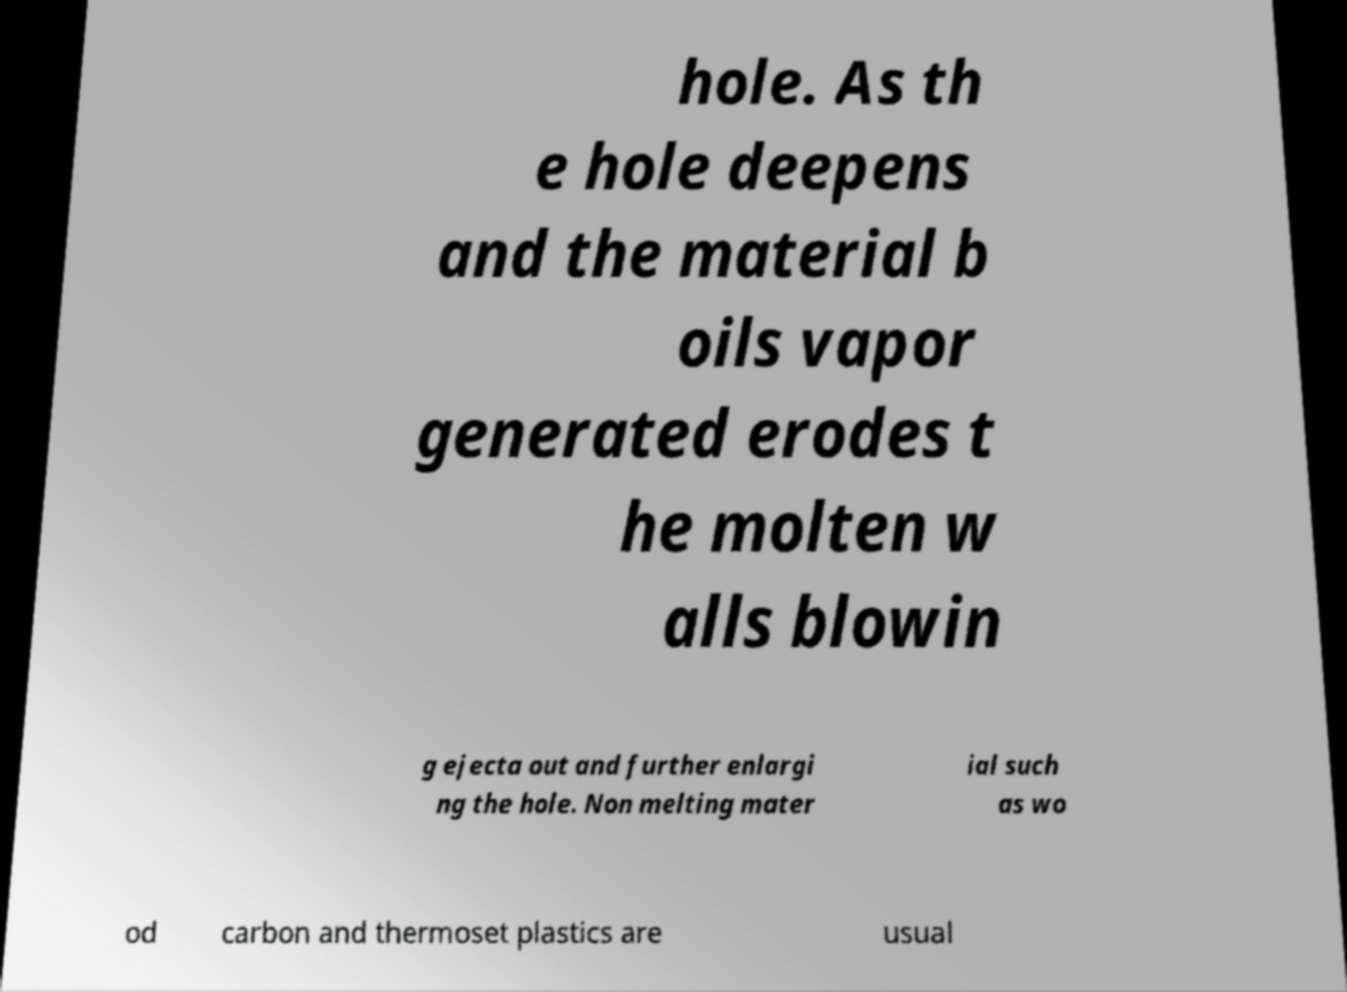I need the written content from this picture converted into text. Can you do that? hole. As th e hole deepens and the material b oils vapor generated erodes t he molten w alls blowin g ejecta out and further enlargi ng the hole. Non melting mater ial such as wo od carbon and thermoset plastics are usual 